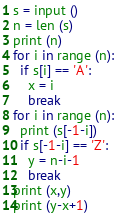Convert code to text. <code><loc_0><loc_0><loc_500><loc_500><_Python_>s = input ()
n = len (s)
print (n)
for i in range (n):
  if s[i] == 'A':
    x = i
    break
for i in range (n):
  print (s[-1-i])
  if s[-1-i] == 'Z':
    y = n-i-1
    break
print (x,y)
print (y-x+1)</code> 